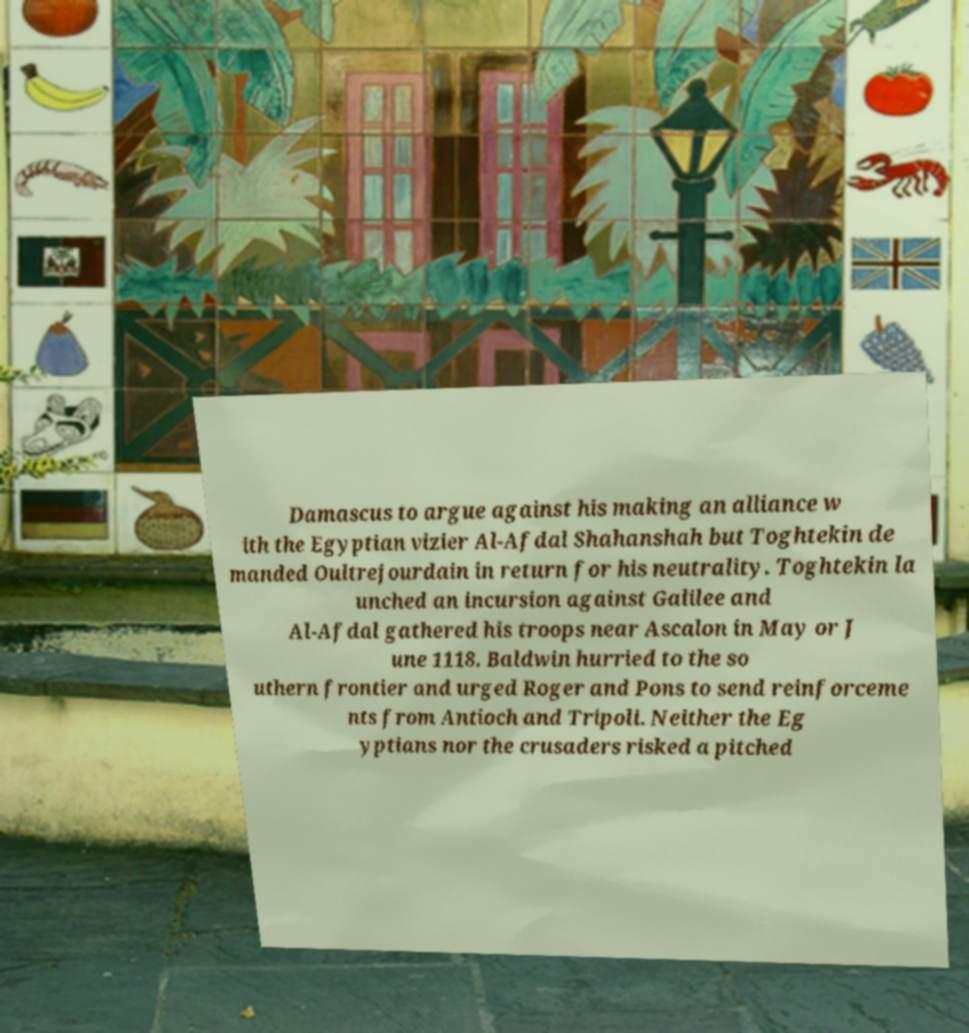Could you assist in decoding the text presented in this image and type it out clearly? Damascus to argue against his making an alliance w ith the Egyptian vizier Al-Afdal Shahanshah but Toghtekin de manded Oultrejourdain in return for his neutrality. Toghtekin la unched an incursion against Galilee and Al-Afdal gathered his troops near Ascalon in May or J une 1118. Baldwin hurried to the so uthern frontier and urged Roger and Pons to send reinforceme nts from Antioch and Tripoli. Neither the Eg yptians nor the crusaders risked a pitched 